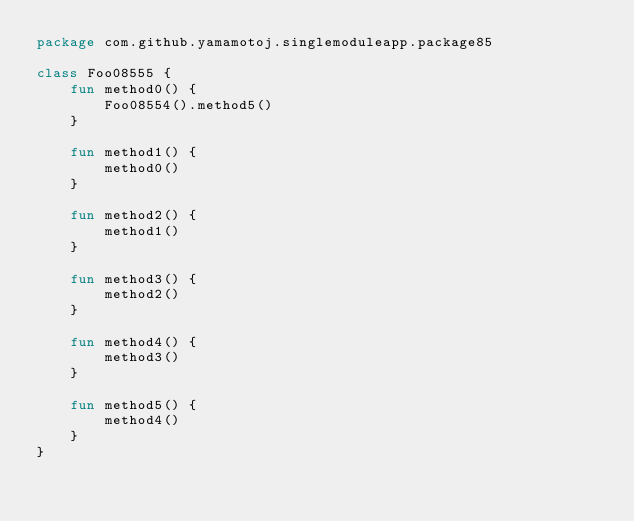<code> <loc_0><loc_0><loc_500><loc_500><_Kotlin_>package com.github.yamamotoj.singlemoduleapp.package85

class Foo08555 {
    fun method0() {
        Foo08554().method5()
    }

    fun method1() {
        method0()
    }

    fun method2() {
        method1()
    }

    fun method3() {
        method2()
    }

    fun method4() {
        method3()
    }

    fun method5() {
        method4()
    }
}
</code> 